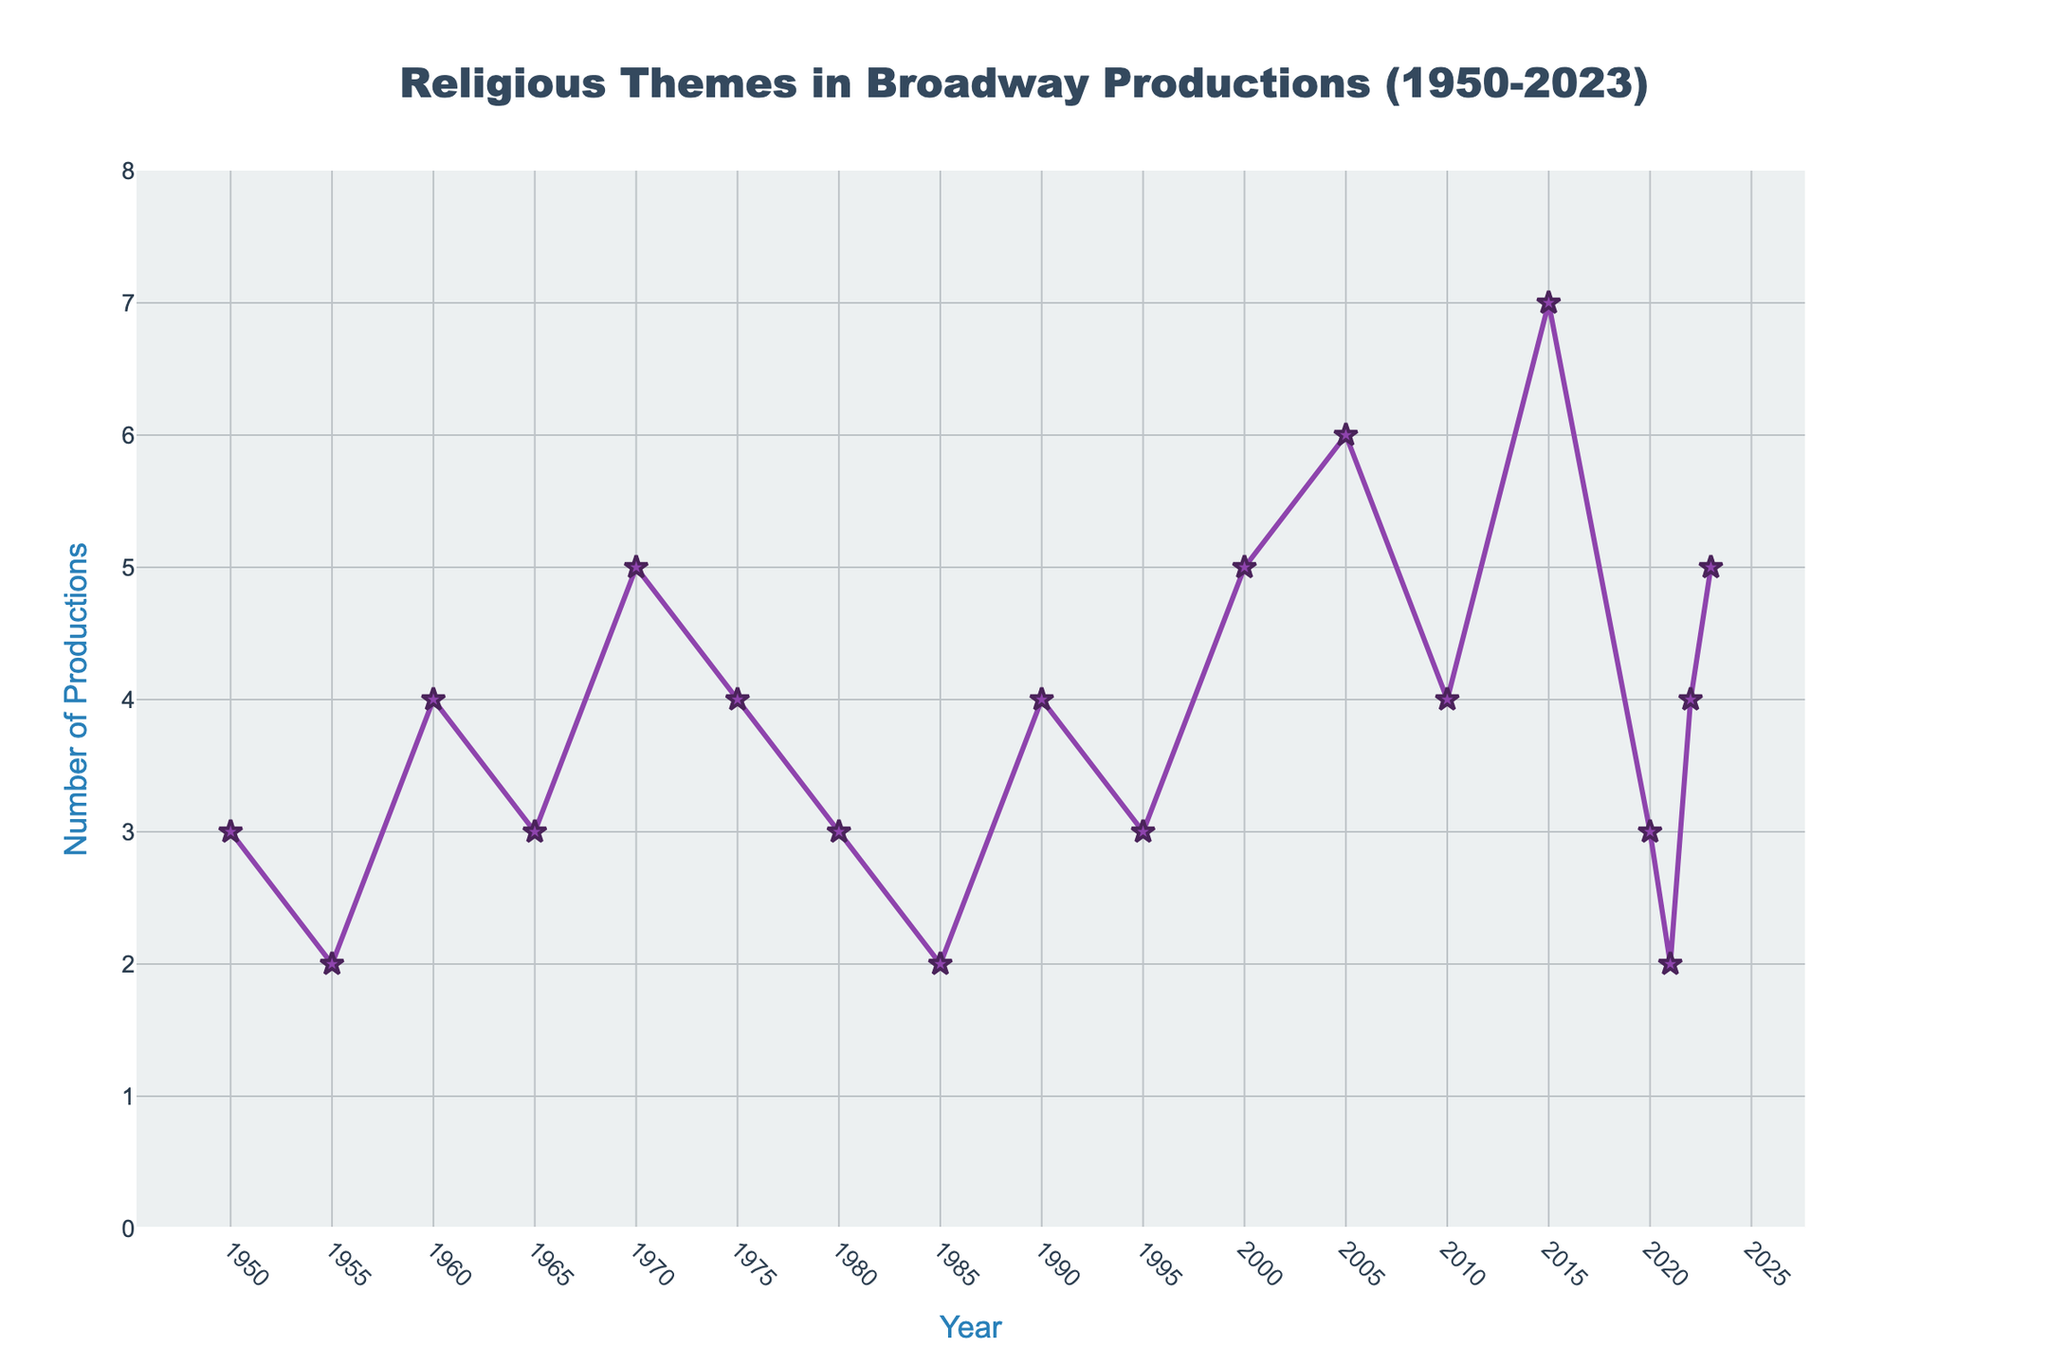What year had the highest number of religious-themed productions? Find the point on the line chart with the highest y-value and note its corresponding x-axis value. The highest point is in 2015 with 7 productions.
Answer: 2015 How many more religious-themed productions were there in 2005 compared to 1955? Find and subtract the number of productions in 1955 from those in 2005: 6 - 2 = 4 more productions.
Answer: 4 What's the average number of religious-themed productions in the decade from 2010 to 2020? Sum the values from 2010 to 2020 and divide by the number of years in this range: (4 + 7 + 3 + 2) / 4 = 16 / 4 = 4.
Answer: 4 Which period showed the largest increase in religious-themed productions over two consecutive points? Compare the differences between consecutive data points and identify the largest: from 2010 to 2015, the increase is 7 - 4 = 3, the largest observed.
Answer: 2010-2015 In which year(s) did the number of religious-themed productions remain constant compared to the previous year? Look for years where the line stays flat, meaning no change between consecutive points: from 1950 to 1955 (3 to 3).
Answer: None By how much did the number of productions change from 1970 to 1980? Subtract the value in 1970 from the value in 1980: 3 - 5 = -2 (a decrease).
Answer: 2 How did the number of religious-themed productions change between 2010 and 2015? Check the y-values for 2010 and 2015 and compute the difference: 7 - 4 = 3 increase.
Answer: Increased by 3 What is the total number of religious-themed productions from 2000 to 2020? Sum the values from 2000 to 2020: 5 + 6 + 4 + 7 + 3 + 2 = 27.
Answer: 27 Which year recorded the same number of religious-themed productions as the year 1980? Identify the y-value for 1980 (3) and find another year with the same value: 1950, 1965, 1980, 2020.
Answer: 1950, 1965, 1980, 2020 Between which consecutive years was there a decrease in the number of religious-themed productions? Observe the downward lines in the chart: from 2020 to 2021 (3 to 2).
Answer: 2020-2021 